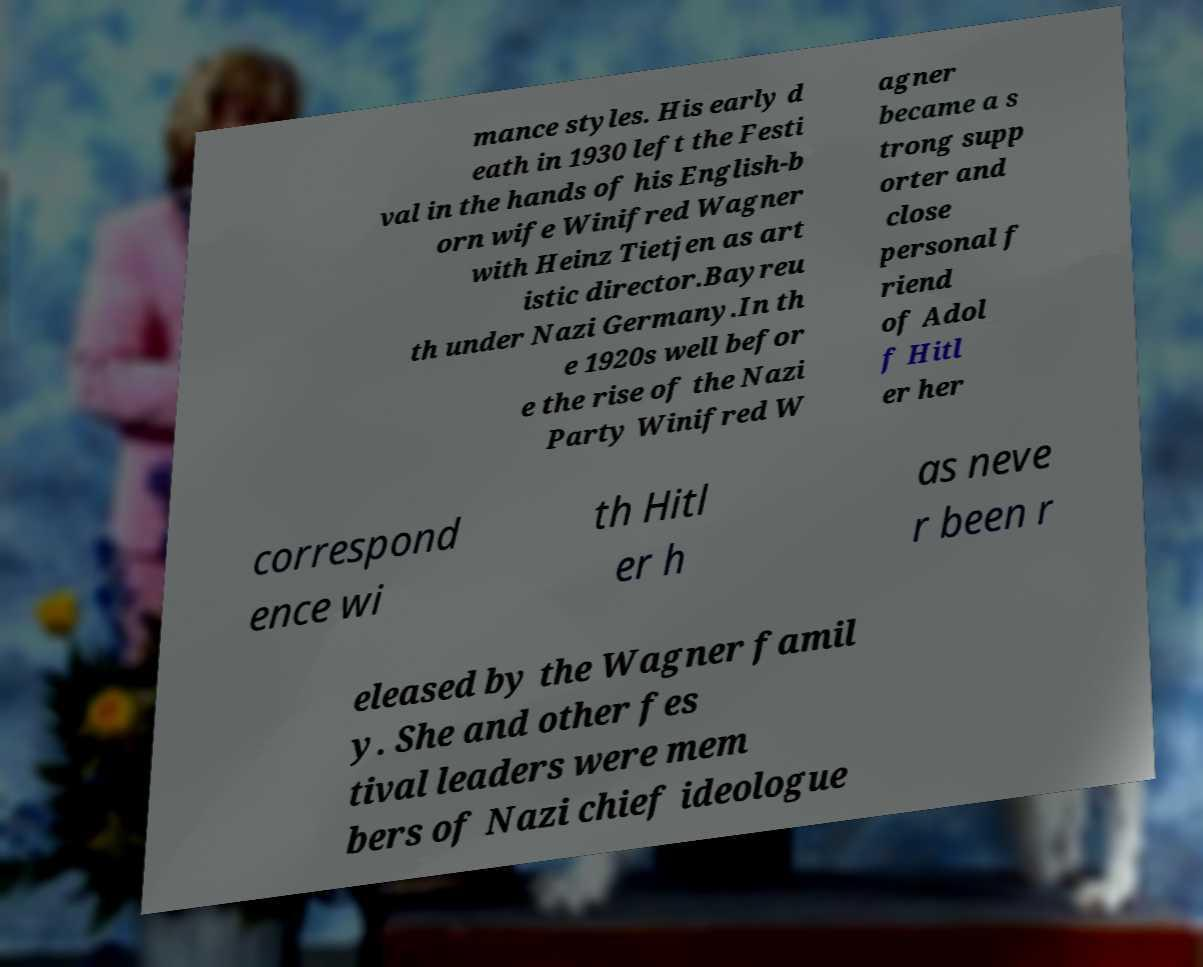Please read and relay the text visible in this image. What does it say? mance styles. His early d eath in 1930 left the Festi val in the hands of his English-b orn wife Winifred Wagner with Heinz Tietjen as art istic director.Bayreu th under Nazi Germany.In th e 1920s well befor e the rise of the Nazi Party Winifred W agner became a s trong supp orter and close personal f riend of Adol f Hitl er her correspond ence wi th Hitl er h as neve r been r eleased by the Wagner famil y. She and other fes tival leaders were mem bers of Nazi chief ideologue 